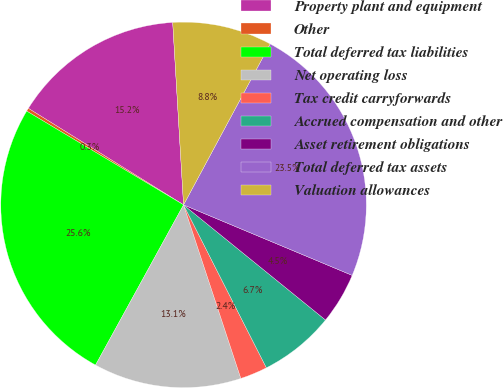Convert chart. <chart><loc_0><loc_0><loc_500><loc_500><pie_chart><fcel>Property plant and equipment<fcel>Other<fcel>Total deferred tax liabilities<fcel>Net operating loss<fcel>Tax credit carryforwards<fcel>Accrued compensation and other<fcel>Asset retirement obligations<fcel>Total deferred tax assets<fcel>Valuation allowances<nl><fcel>15.2%<fcel>0.28%<fcel>25.58%<fcel>13.07%<fcel>2.41%<fcel>6.67%<fcel>4.54%<fcel>23.45%<fcel>8.8%<nl></chart> 